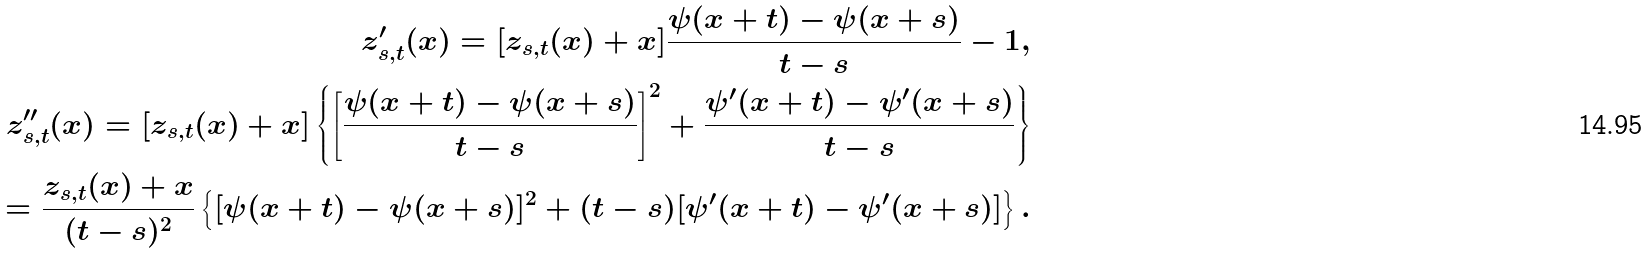<formula> <loc_0><loc_0><loc_500><loc_500>z ^ { \prime } _ { s , t } ( x ) = [ z _ { s , t } ( x ) + x ] \frac { \psi ( x + t ) - \psi ( x + s ) } { t - s } - 1 , \\ z ^ { \prime \prime } _ { s , t } ( x ) = [ z _ { s , t } ( x ) + x ] \left \{ \left [ \frac { \psi ( x + t ) - \psi ( x + s ) } { t - s } \right ] ^ { 2 } + \frac { \psi ^ { \prime } ( x + t ) - \psi ^ { \prime } ( x + s ) } { t - s } \right \} \\ = \frac { z _ { s , t } ( x ) + x } { ( t - s ) ^ { 2 } } \left \{ { [ \psi ( x + t ) - \psi ( x + s ) ] ^ { 2 } } + ( t - s ) [ \psi ^ { \prime } ( x + t ) - \psi ^ { \prime } ( x + s ) ] \right \} .</formula> 